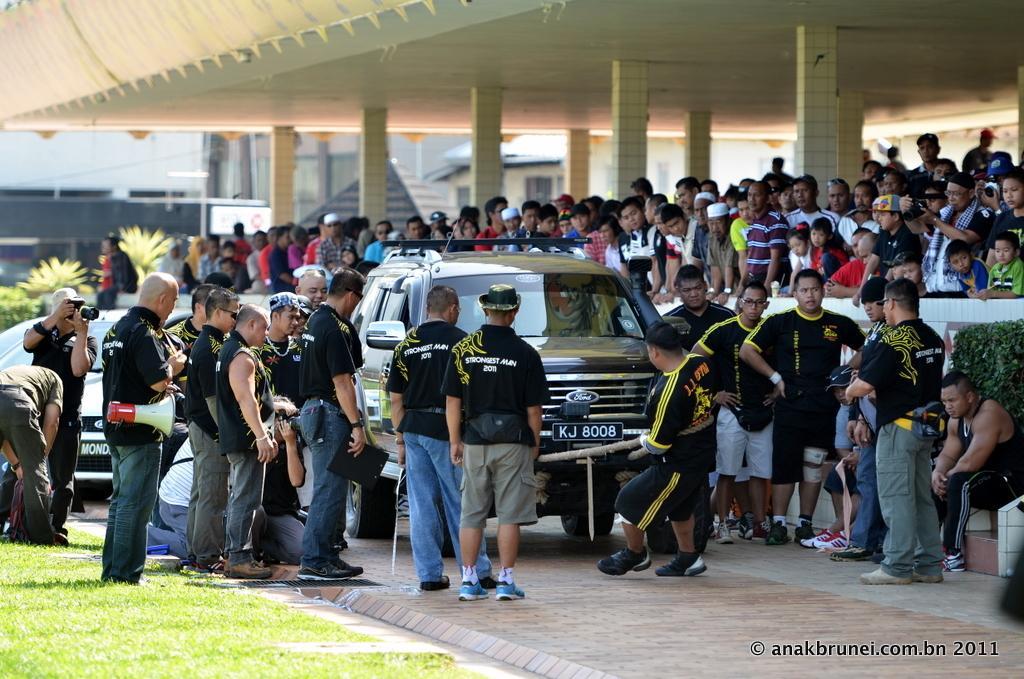Please provide a concise description of this image. There are so much crowd standing under the roof top of building and watching at the car which is pulled by a man with rope. 